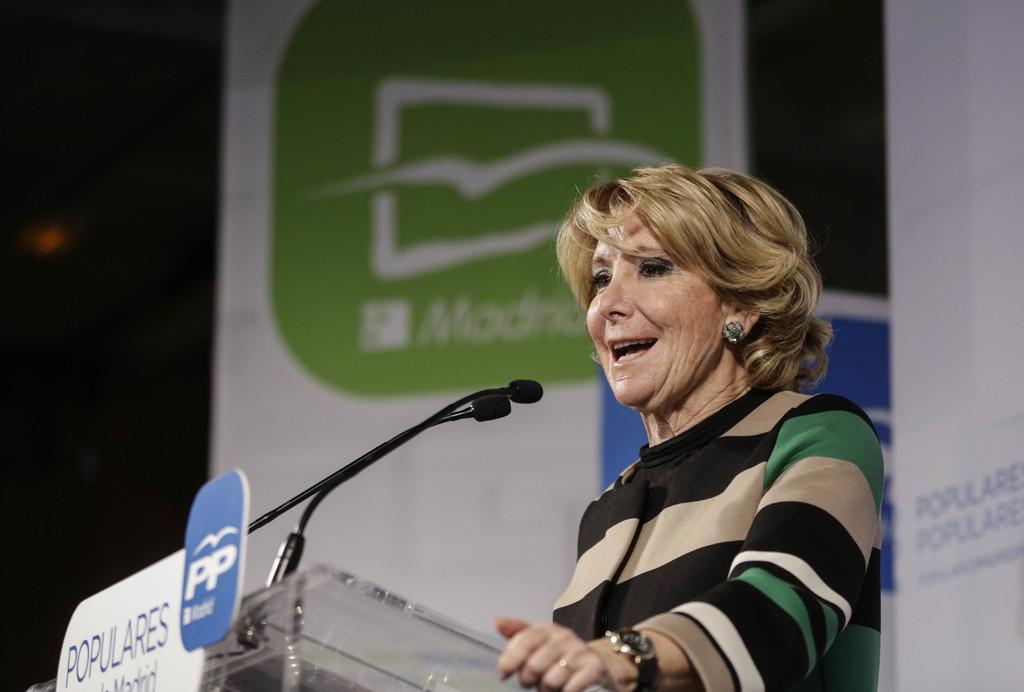Please provide a concise description of this image. In the image in the center we can see one person standing and smiling,which we can see on her face. In front of her,there is a stand,microphones and banners. In the background there is a banner. 